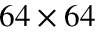<formula> <loc_0><loc_0><loc_500><loc_500>6 4 \times 6 4</formula> 